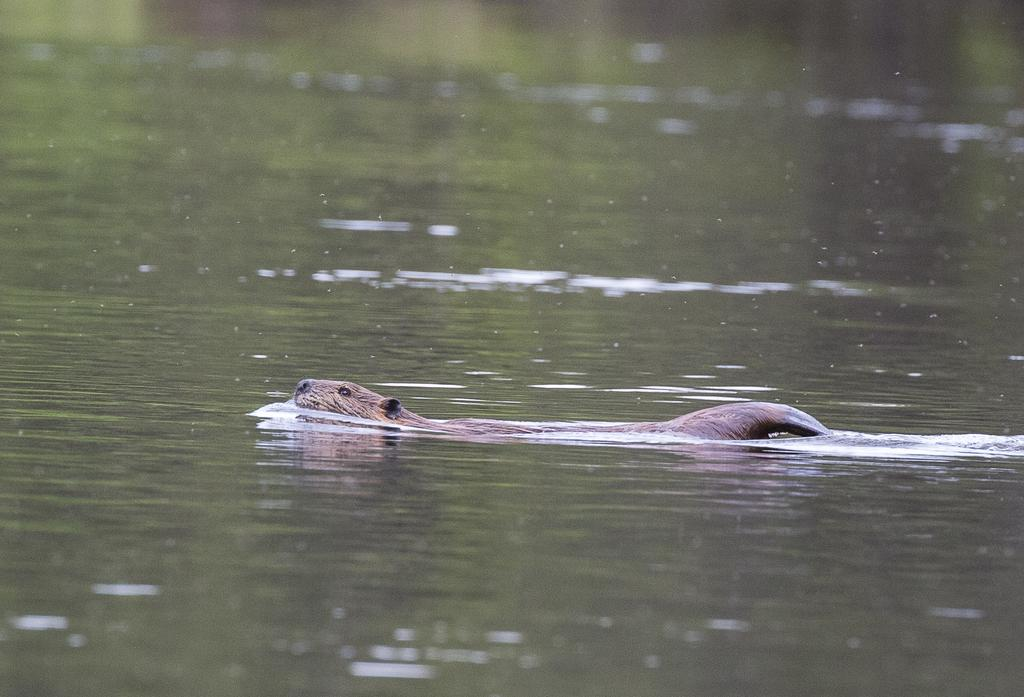What is the main subject of the image? There is an animal in the image. Can you describe the animal's position or activity in the image? The animal is floating on the water. What type of train can be seen in the image? There is no train present in the image; it features an animal floating on the water. How does the animal contribute to the harmony of the image? The concept of harmony is subjective and cannot be definitively determined from the image alone. 